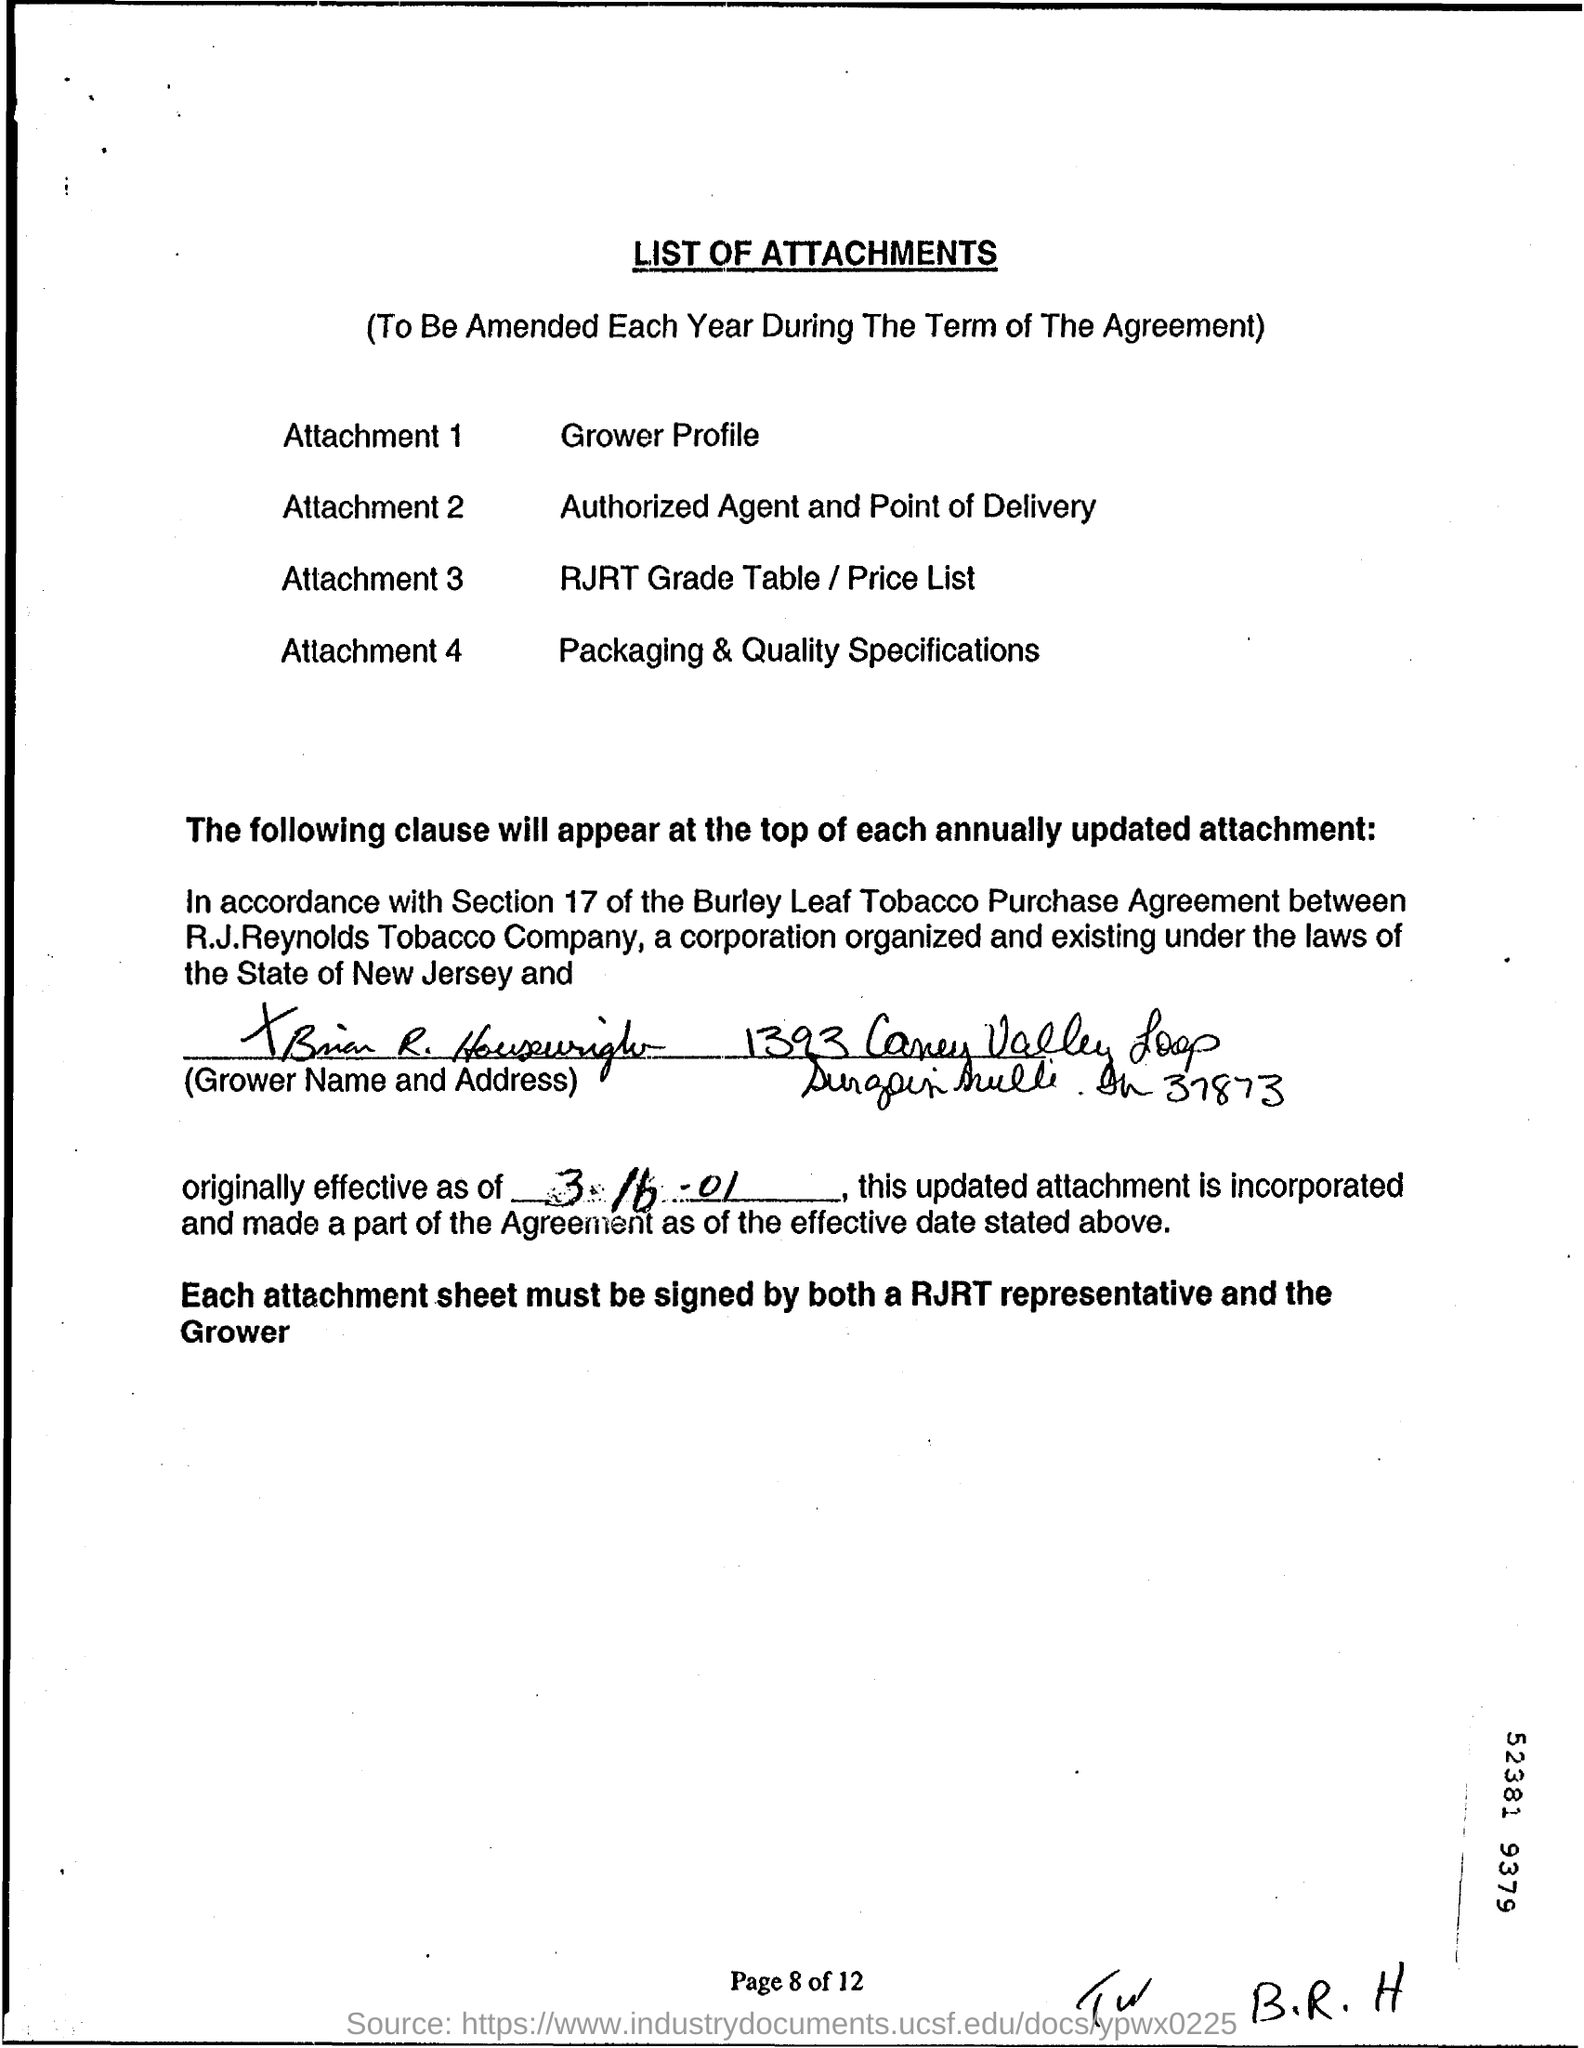What is Attachment 2?
Keep it short and to the point. Authorized agent and point of delivery. Who must sign each attachment sheet?
Provide a short and direct response. RJRT representative and the Grower. When is the agreement effective from?
Offer a very short reply. 3-16-01. What is the page number?
Ensure brevity in your answer.  8. What is the document title?
Provide a short and direct response. List of attachments. 